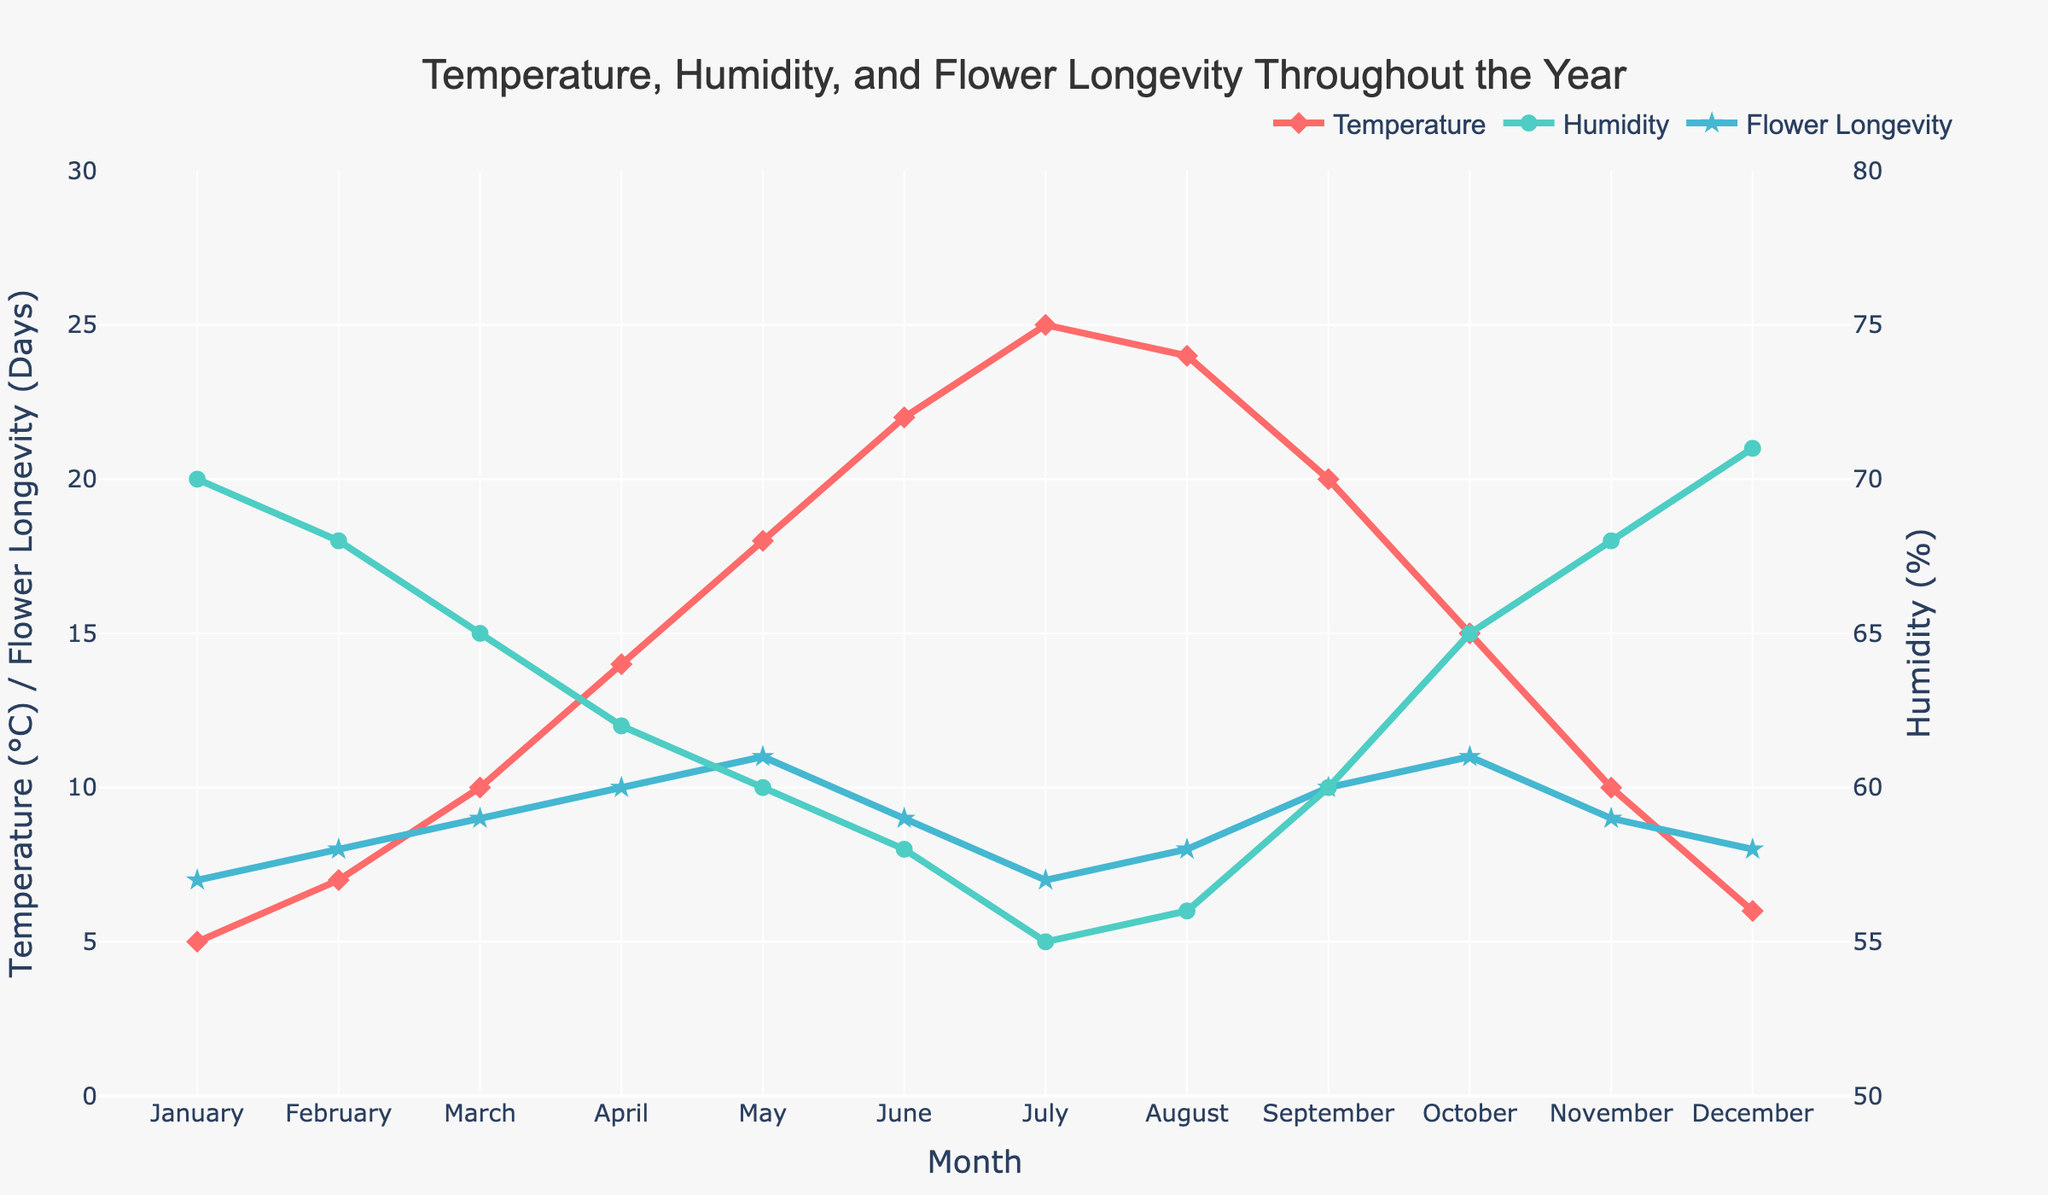What is the trend of the 'Average Flower Longevity' across the year? From January to May, flower longevity increases steadily from 7 days to 11 days. It then declines to 7 days in July, increases again until October, reaching another peak at 11 days, and finally decreases slightly to end at 8 days in December.
Answer: Peaks in May and October with 11 days; dips in July with 7 days How does 'Average Humidity' vary compared to 'Average Temperature' from January to December? While the temperature generally increases from January to July and then decreases towards December, humidity peaks in January and December but reaches its lowest values around June to August. These two trends are inversely related throughout the year.
Answer: Inversely related In which month is the 'Average Temperature' at its highest? The highest average temperature is observed in July, which is 25°C.
Answer: July When does 'Average Flower Longevity' reach its lowest point? The lowest average flower longevity is in January and July, both months showing a value of 7 days.
Answer: January and July Which month shows the highest 'Average Humidity', and what is that value? December shows the highest average humidity at 71%.
Answer: December, 71% What is the range of 'Average Temperature' over the year? The temperature ranges from a minimum of 5°C in January to a maximum of 25°C in July.
Answer: 5°C to 25°C Is there a month where both 'Average Temperature' and 'Average Humidity' reach peak values simultaneously? By visual inspection, there is no month where both temperature and humidity reach their peak values at the same time. The highest temperature occurs in July, whereas the highest humidity occurs in December.
Answer: No Calculate the combined temperature and flower longevity value for March. In March, the average temperature is 10°C and flower longevity is 9 days. The combined value is 10 + 9 = 19.
Answer: 19 Compare the 'Average Flower Longevity' in June and November. Which is greater and by how much? In June, the average flower longevity is 9 days, whereas in November it is 9 days. They are equal.
Answer: Equal What is the visual characteristic used to represent 'Average Temperature'? The 'Average Temperature' is represented by a red line with diamond markers.
Answer: Red line with diamond markers 